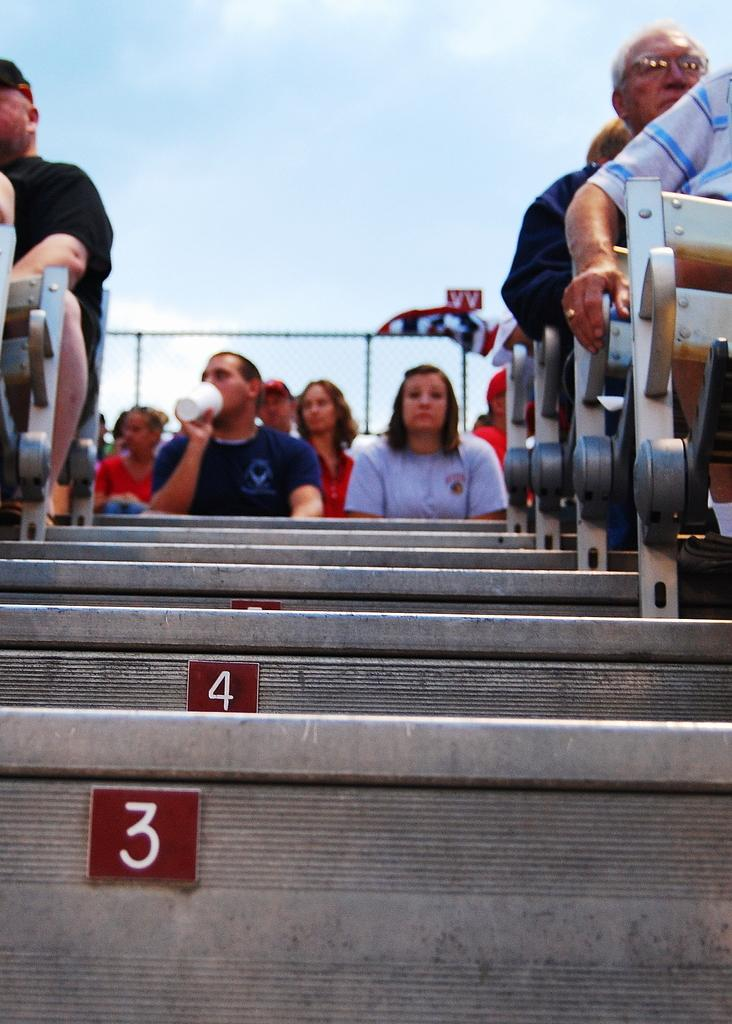What are the people in the image doing? The people in the image are sitting. Can you describe the man in the center of the image? The man in the center of the image is sitting and holding a glass. What architectural feature can be seen in the image? There are stairs in the image. What is visible in the background of the image? There is a board and the sky visible in the background of the image. What is the rate of the iron competition in the image? There is no iron competition or rate mentioned in the image. The image features people sitting, a man holding a glass, stairs, a board, and the sky in the background. 